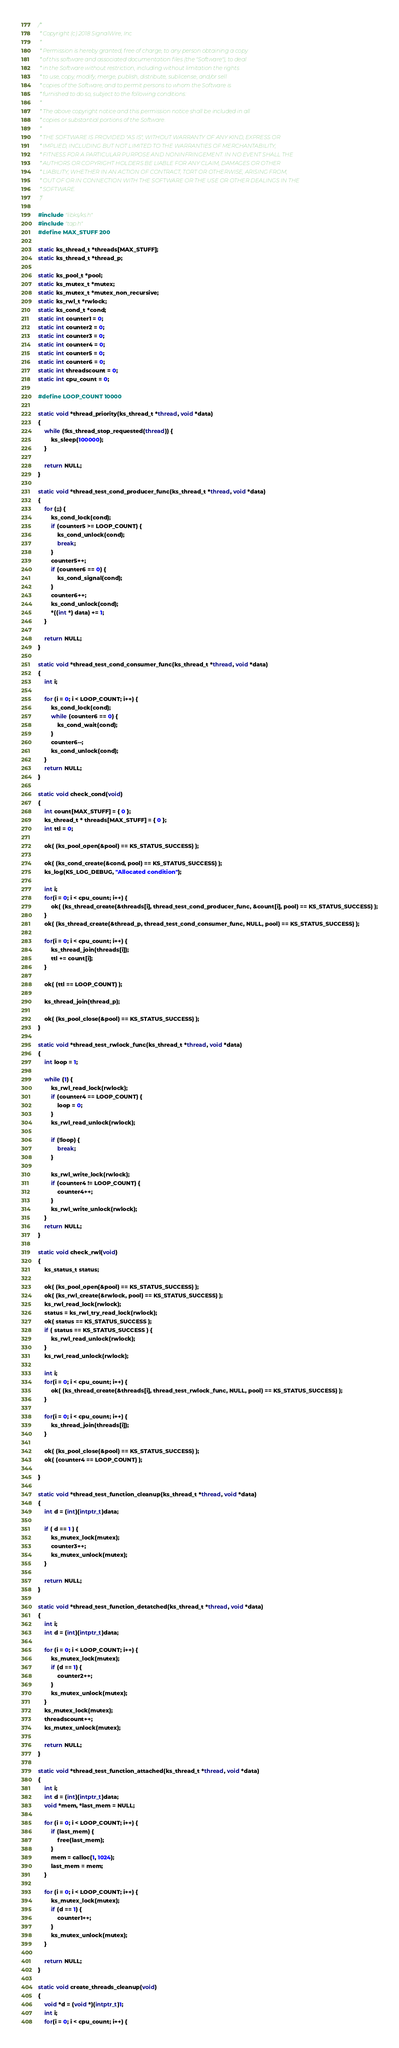<code> <loc_0><loc_0><loc_500><loc_500><_C_>/*
 * Copyright (c) 2018 SignalWire, Inc
 *
 * Permission is hereby granted, free of charge, to any person obtaining a copy
 * of this software and associated documentation files (the "Software"), to deal
 * in the Software without restriction, including without limitation the rights
 * to use, copy, modify, merge, publish, distribute, sublicense, and/or sell
 * copies of the Software, and to permit persons to whom the Software is
 * furnished to do so, subject to the following conditions:
 *
 * The above copyright notice and this permission notice shall be included in all
 * copies or substantial portions of the Software.
 *
 * THE SOFTWARE IS PROVIDED "AS IS", WITHOUT WARRANTY OF ANY KIND, EXPRESS OR
 * IMPLIED, INCLUDING BUT NOT LIMITED TO THE WARRANTIES OF MERCHANTABILITY,
 * FITNESS FOR A PARTICULAR PURPOSE AND NONINFRINGEMENT. IN NO EVENT SHALL THE
 * AUTHORS OR COPYRIGHT HOLDERS BE LIABLE FOR ANY CLAIM, DAMAGES OR OTHER
 * LIABILITY, WHETHER IN AN ACTION OF CONTRACT, TORT OR OTHERWISE, ARISING FROM,
 * OUT OF OR IN CONNECTION WITH THE SOFTWARE OR THE USE OR OTHER DEALINGS IN THE
 * SOFTWARE.
 */

#include "libks/ks.h"
#include "tap.h"
#define MAX_STUFF 200

static ks_thread_t *threads[MAX_STUFF];
static ks_thread_t *thread_p;

static ks_pool_t *pool;
static ks_mutex_t *mutex;
static ks_mutex_t *mutex_non_recursive;
static ks_rwl_t *rwlock;
static ks_cond_t *cond;
static int counter1 = 0;
static int counter2 = 0;
static int counter3 = 0;
static int counter4 = 0;
static int counter5 = 0;
static int counter6 = 0;
static int threadscount = 0;
static int cpu_count = 0;

#define LOOP_COUNT 10000

static void *thread_priority(ks_thread_t *thread, void *data)
{
	while (!ks_thread_stop_requested(thread)) {
		ks_sleep(100000);
	}

	return NULL;
}

static void *thread_test_cond_producer_func(ks_thread_t *thread, void *data)
{
	for (;;) {
		ks_cond_lock(cond);
		if (counter5 >= LOOP_COUNT) {
			ks_cond_unlock(cond);
			break;
		}
		counter5++;
		if (counter6 == 0) {
			ks_cond_signal(cond);
		}
		counter6++;
		ks_cond_unlock(cond);
		*((int *) data) += 1;
	}

    return NULL;
}

static void *thread_test_cond_consumer_func(ks_thread_t *thread, void *data)
{
	int i;

	for (i = 0; i < LOOP_COUNT; i++) {
		ks_cond_lock(cond);
		while (counter6 == 0) {
			ks_cond_wait(cond);
		}
		counter6--;
		ks_cond_unlock(cond);
	}
    return NULL;
}

static void check_cond(void)
{
	int count[MAX_STUFF] = { 0 };
	ks_thread_t * threads[MAX_STUFF] = { 0 };
	int ttl = 0;

	ok( (ks_pool_open(&pool) == KS_STATUS_SUCCESS) );

	ok( (ks_cond_create(&cond, pool) == KS_STATUS_SUCCESS) );
	ks_log(KS_LOG_DEBUG, "Allocated condition");

	int i;
	for(i = 0; i < cpu_count; i++) {
		ok( (ks_thread_create(&threads[i], thread_test_cond_producer_func, &count[i], pool) == KS_STATUS_SUCCESS) );
	}
	ok( (ks_thread_create(&thread_p, thread_test_cond_consumer_func, NULL, pool) == KS_STATUS_SUCCESS) );

	for(i = 0; i < cpu_count; i++) {
		ks_thread_join(threads[i]);
		ttl += count[i];
	}

	ok( (ttl == LOOP_COUNT) );

	ks_thread_join(thread_p);

	ok( (ks_pool_close(&pool) == KS_STATUS_SUCCESS) );
}

static void *thread_test_rwlock_func(ks_thread_t *thread, void *data)
{
    int loop = 1;

    while (1) {
        ks_rwl_read_lock(rwlock);
        if (counter4 == LOOP_COUNT) {
            loop = 0;
		}
        ks_rwl_read_unlock(rwlock);

        if (!loop) {
            break;
		}

        ks_rwl_write_lock(rwlock);
        if (counter4 != LOOP_COUNT) {
			counter4++;
        }
        ks_rwl_write_unlock(rwlock);
    }
    return NULL;
}

static void check_rwl(void)
{
	ks_status_t status;

	ok( (ks_pool_open(&pool) == KS_STATUS_SUCCESS) );
	ok( (ks_rwl_create(&rwlock, pool) == KS_STATUS_SUCCESS) );
	ks_rwl_read_lock(rwlock);
	status = ks_rwl_try_read_lock(rwlock);
	ok( status == KS_STATUS_SUCCESS );
	if ( status == KS_STATUS_SUCCESS ) {
		ks_rwl_read_unlock(rwlock);
	}
	ks_rwl_read_unlock(rwlock);

	int i;
	for(i = 0; i < cpu_count; i++) {
		ok( (ks_thread_create(&threads[i], thread_test_rwlock_func, NULL, pool) == KS_STATUS_SUCCESS) );
	}

	for(i = 0; i < cpu_count; i++) {
		ks_thread_join(threads[i]);
	}

	ok( (ks_pool_close(&pool) == KS_STATUS_SUCCESS) );
	ok( (counter4 == LOOP_COUNT) );

}

static void *thread_test_function_cleanup(ks_thread_t *thread, void *data)
{
	int d = (int)(intptr_t)data;

	if ( d == 1 ) {
		ks_mutex_lock(mutex);
		counter3++;
		ks_mutex_unlock(mutex);
	}

	return NULL;
}

static void *thread_test_function_detatched(ks_thread_t *thread, void *data)
{
	int i;
	int d = (int)(intptr_t)data;

	for (i = 0; i < LOOP_COUNT; i++) {
		ks_mutex_lock(mutex);
		if (d == 1) {
			counter2++;
		}
		ks_mutex_unlock(mutex);
	}
	ks_mutex_lock(mutex);
	threadscount++;
	ks_mutex_unlock(mutex);

	return NULL;
}

static void *thread_test_function_attached(ks_thread_t *thread, void *data)
{
	int i;
	int d = (int)(intptr_t)data;
	void *mem, *last_mem = NULL;

	for (i = 0; i < LOOP_COUNT; i++) {
		if (last_mem) {
			free(last_mem);
		}
		mem = calloc(1, 1024);
		last_mem = mem;
	}

	for (i = 0; i < LOOP_COUNT; i++) {
		ks_mutex_lock(mutex);
		if (d == 1) {
			counter1++;
		}
		ks_mutex_unlock(mutex);
	}

	return NULL;
}

static void create_threads_cleanup(void)
{
	void *d = (void *)(intptr_t)1;
	int i;
	for(i = 0; i < cpu_count; i++) {</code> 